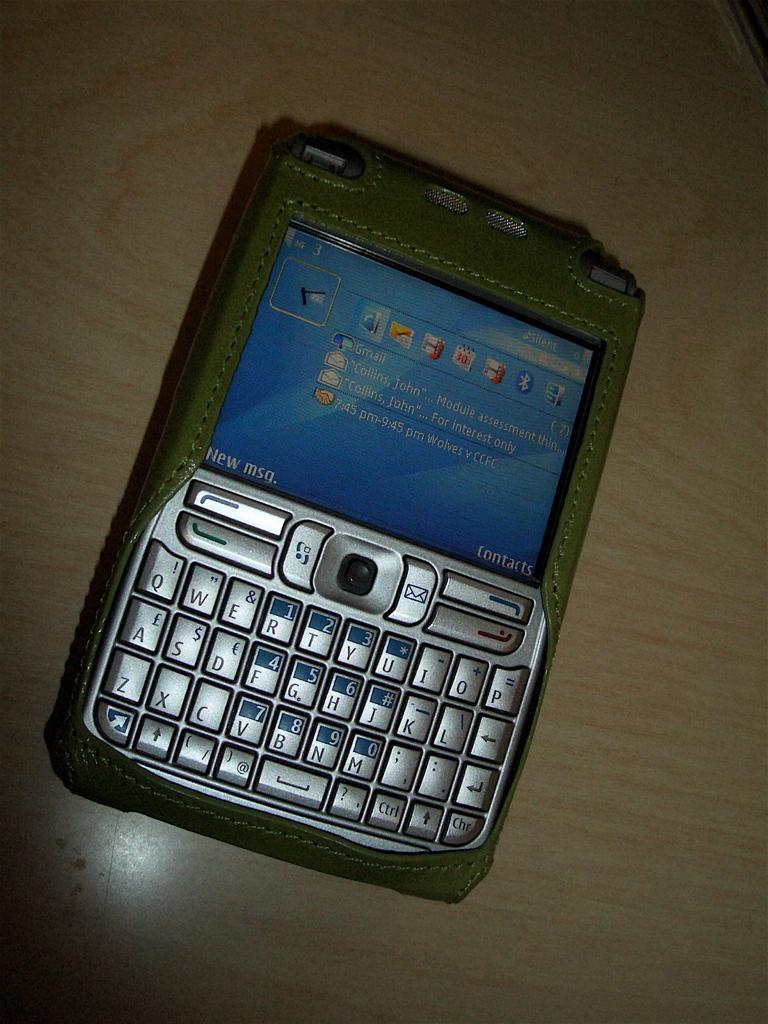What is the menu button on the bottom of right screen for?
Provide a short and direct response. Contacts. 